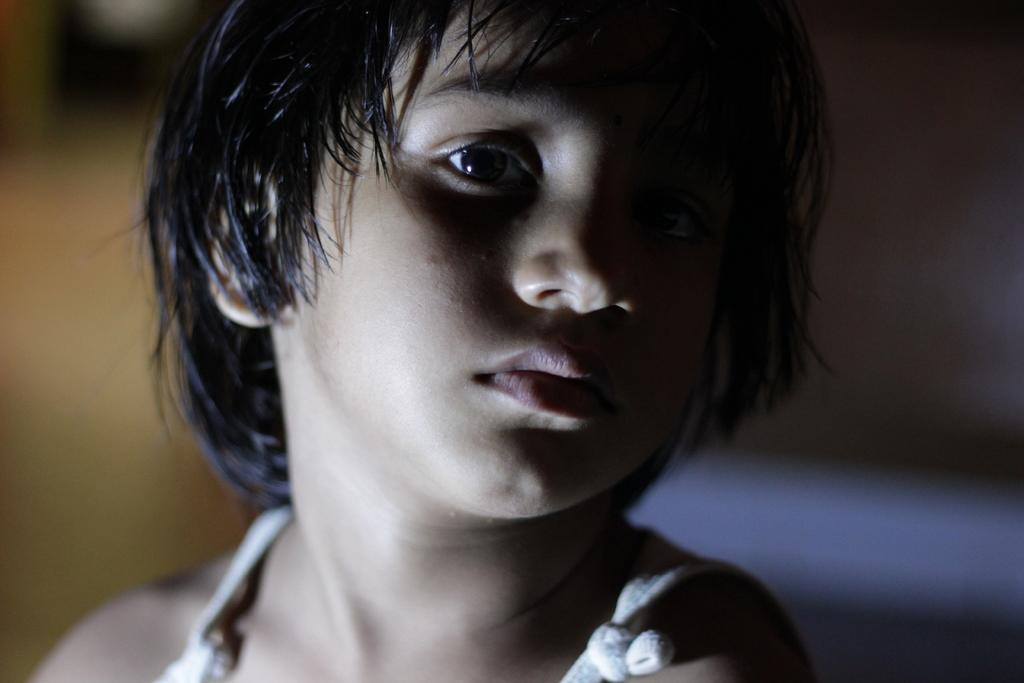Who is the main subject in the image? There is a girl in the image. What is the girl doing in the image? The girl is looking at a picture. Can you describe the background of the image? The background of the image is blurred. What type of swim does the girl participate in during the image? There is no indication of swimming or any water-related activity in the image. 